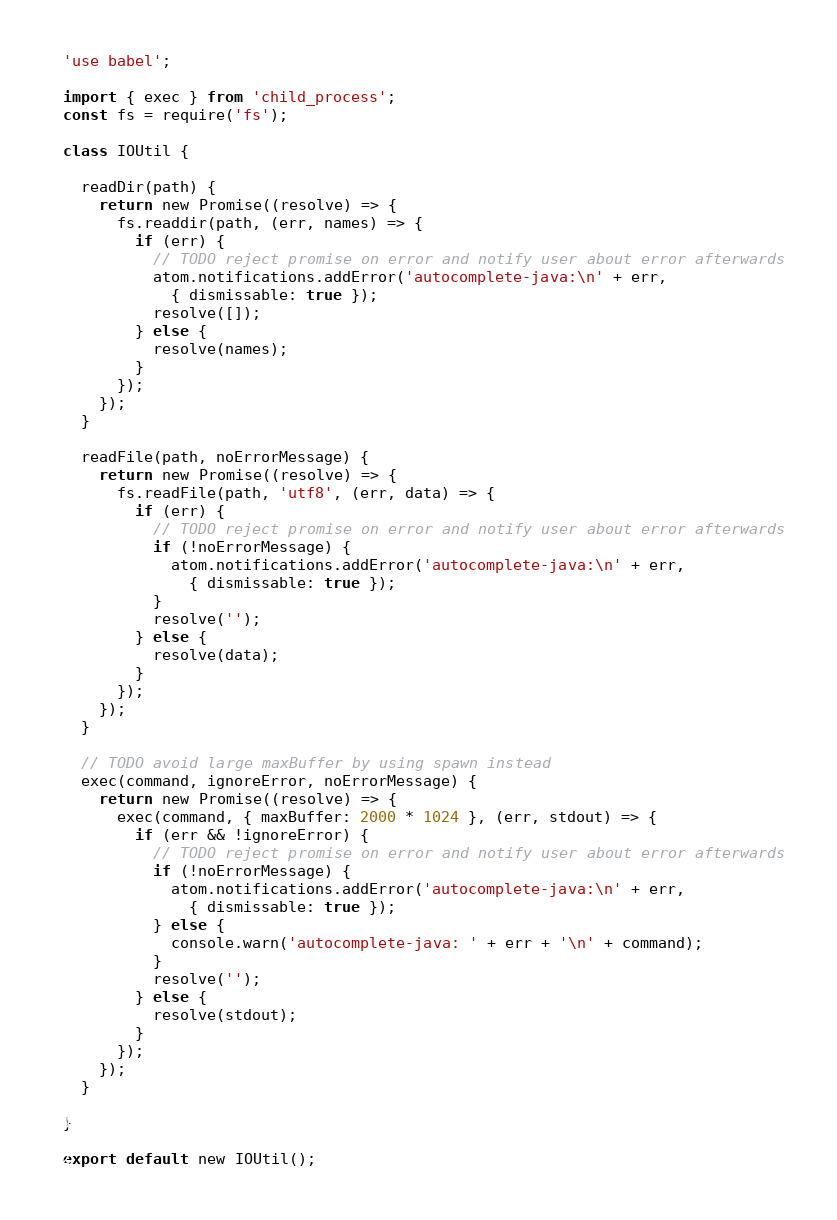<code> <loc_0><loc_0><loc_500><loc_500><_JavaScript_>'use babel';

import { exec } from 'child_process';
const fs = require('fs');

class IOUtil {

  readDir(path) {
    return new Promise((resolve) => {
      fs.readdir(path, (err, names) => {
        if (err) {
          // TODO reject promise on error and notify user about error afterwards
          atom.notifications.addError('autocomplete-java:\n' + err,
            { dismissable: true });
          resolve([]);
        } else {
          resolve(names);
        }
      });
    });
  }

  readFile(path, noErrorMessage) {
    return new Promise((resolve) => {
      fs.readFile(path, 'utf8', (err, data) => {
        if (err) {
          // TODO reject promise on error and notify user about error afterwards
          if (!noErrorMessage) {
            atom.notifications.addError('autocomplete-java:\n' + err,
              { dismissable: true });
          }
          resolve('');
        } else {
          resolve(data);
        }
      });
    });
  }

  // TODO avoid large maxBuffer by using spawn instead
  exec(command, ignoreError, noErrorMessage) {
    return new Promise((resolve) => {
      exec(command, { maxBuffer: 2000 * 1024 }, (err, stdout) => {
        if (err && !ignoreError) {
          // TODO reject promise on error and notify user about error afterwards
          if (!noErrorMessage) {
            atom.notifications.addError('autocomplete-java:\n' + err,
              { dismissable: true });
          } else {
            console.warn('autocomplete-java: ' + err + '\n' + command);
          }
          resolve('');
        } else {
          resolve(stdout);
        }
      });
    });
  }

}

export default new IOUtil();
</code> 